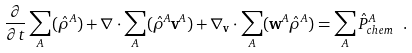Convert formula to latex. <formula><loc_0><loc_0><loc_500><loc_500>\frac { \partial } { \partial t } \sum _ { A } ( \hat { \rho } ^ { A } ) + \nabla \cdot \sum _ { A } ( \hat { \rho } ^ { A } \mathbf v ^ { A } ) + \nabla _ { \mathbf v } \cdot \sum _ { A } ( \mathbf w ^ { A } \hat { \rho } ^ { A } ) = \sum _ { A } \hat { P } ^ { A } _ { c h e m } \ .</formula> 